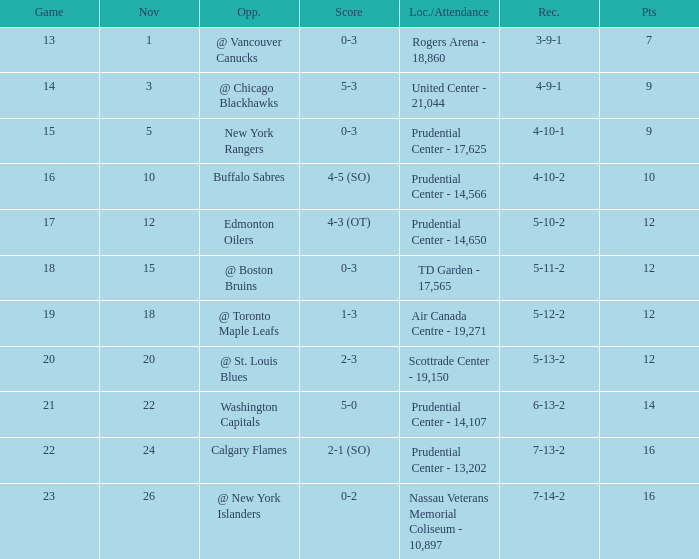What is the highest amount of points possible? 16.0. 